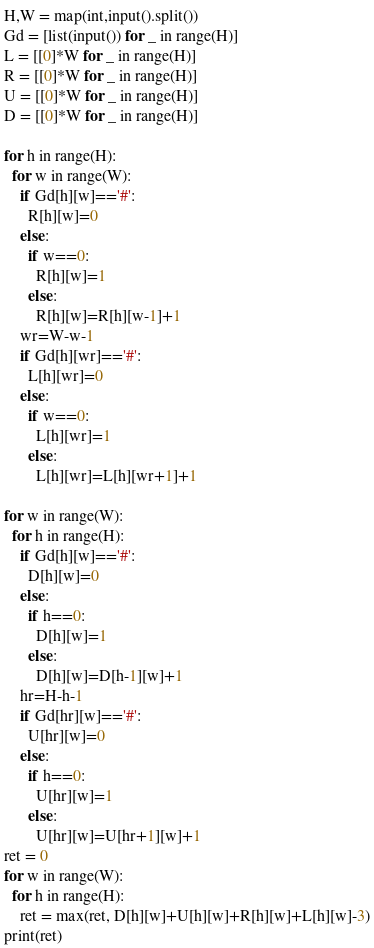<code> <loc_0><loc_0><loc_500><loc_500><_Python_>H,W = map(int,input().split())
Gd = [list(input()) for _ in range(H)]
L = [[0]*W for _ in range(H)]
R = [[0]*W for _ in range(H)]
U = [[0]*W for _ in range(H)]
D = [[0]*W for _ in range(H)]

for h in range(H):
  for w in range(W):
    if Gd[h][w]=='#':
      R[h][w]=0
    else:
      if w==0:
        R[h][w]=1
      else:
        R[h][w]=R[h][w-1]+1
    wr=W-w-1
    if Gd[h][wr]=='#':
      L[h][wr]=0
    else:
      if w==0:
        L[h][wr]=1
      else:
        L[h][wr]=L[h][wr+1]+1

for w in range(W):
  for h in range(H):
    if Gd[h][w]=='#':
      D[h][w]=0
    else:
      if h==0:
        D[h][w]=1
      else:
        D[h][w]=D[h-1][w]+1
    hr=H-h-1
    if Gd[hr][w]=='#':
      U[hr][w]=0
    else:
      if h==0:
        U[hr][w]=1
      else:
        U[hr][w]=U[hr+1][w]+1
ret = 0
for w in range(W):
  for h in range(H):
    ret = max(ret, D[h][w]+U[h][w]+R[h][w]+L[h][w]-3)
print(ret)</code> 